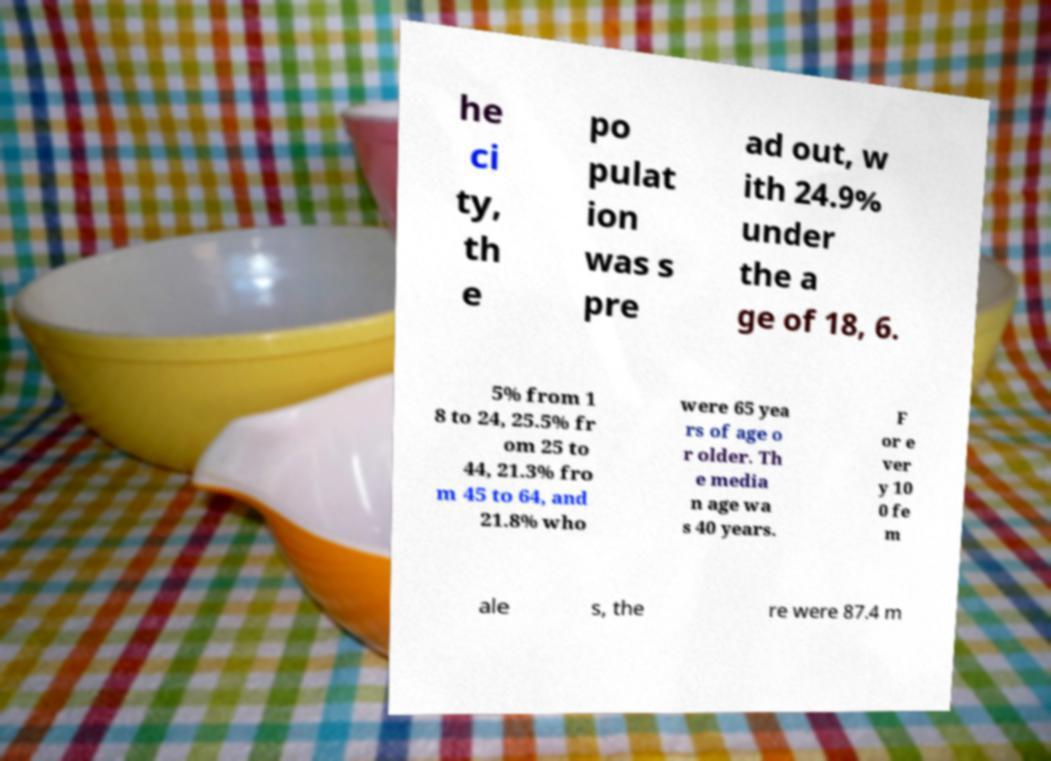I need the written content from this picture converted into text. Can you do that? he ci ty, th e po pulat ion was s pre ad out, w ith 24.9% under the a ge of 18, 6. 5% from 1 8 to 24, 25.5% fr om 25 to 44, 21.3% fro m 45 to 64, and 21.8% who were 65 yea rs of age o r older. Th e media n age wa s 40 years. F or e ver y 10 0 fe m ale s, the re were 87.4 m 